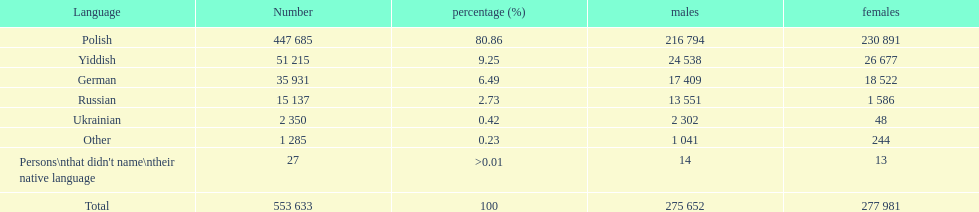What's the count of german-speaking males and females? 35931. 